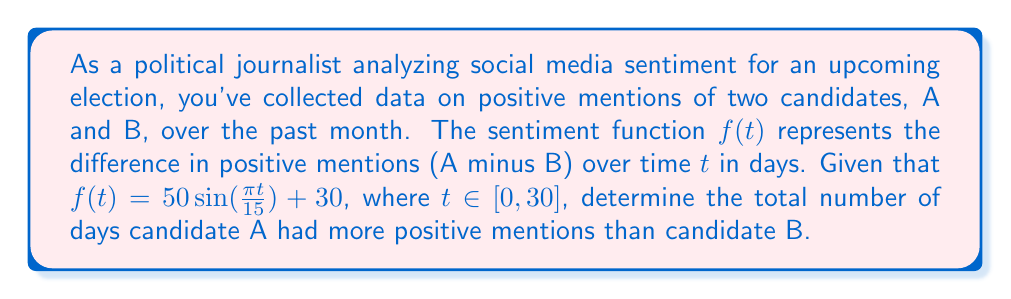Could you help me with this problem? To solve this problem, we need to follow these steps:

1) Candidate A has more positive mentions when $f(t) > 0$. We need to find the number of days where this is true.

2) Set up the inequality:
   $50\sin(\frac{\pi t}{15}) + 30 > 0$

3) Solve the inequality:
   $50\sin(\frac{\pi t}{15}) > -30$
   $\sin(\frac{\pi t}{15}) > -0.6$

4) The sine function is always greater than -0.6 except when it's in its most negative part of the cycle. We need to find when it's less than or equal to -0.6.

5) Solve:
   $\sin(\frac{\pi t}{15}) \leq -0.6$
   $\frac{\pi t}{15} = \arcsin(-0.6) + 2\pi n$ or $\frac{\pi t}{15} = \pi - \arcsin(-0.6) + 2\pi n$, where $n$ is an integer

6) Solving for $t$:
   $t = \frac{15}{\pi}(\arcsin(-0.6) + 2\pi n)$ or $t = \frac{15}{\pi}(\pi - \arcsin(-0.6) + 2\pi n)$

7) In the interval $[0, 30]$, this occurs approximately at:
   $t \approx 23.6$ to $t \approx 26.4$

8) This interval is about 2.8 days long.

9) Therefore, candidate A had more positive mentions for approximately 30 - 2.8 = 27.2 days.

10) Since we're asked for the total number of days, we round down to 27 days.
Answer: 27 days 